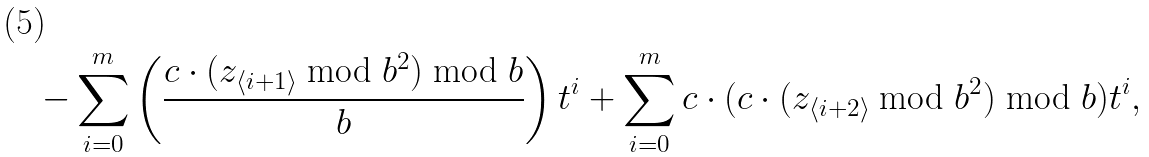Convert formula to latex. <formula><loc_0><loc_0><loc_500><loc_500>- \sum _ { i = 0 } ^ { m } \left ( \frac { c \cdot ( z _ { \langle i + 1 \rangle } \bmod { b ^ { 2 } } ) \bmod { b } } { b } \right ) t ^ { i } + \sum _ { i = 0 } ^ { m } c \cdot ( c \cdot ( z _ { \langle i + 2 \rangle } \bmod { b ^ { 2 } } ) \bmod { b } ) t ^ { i } ,</formula> 